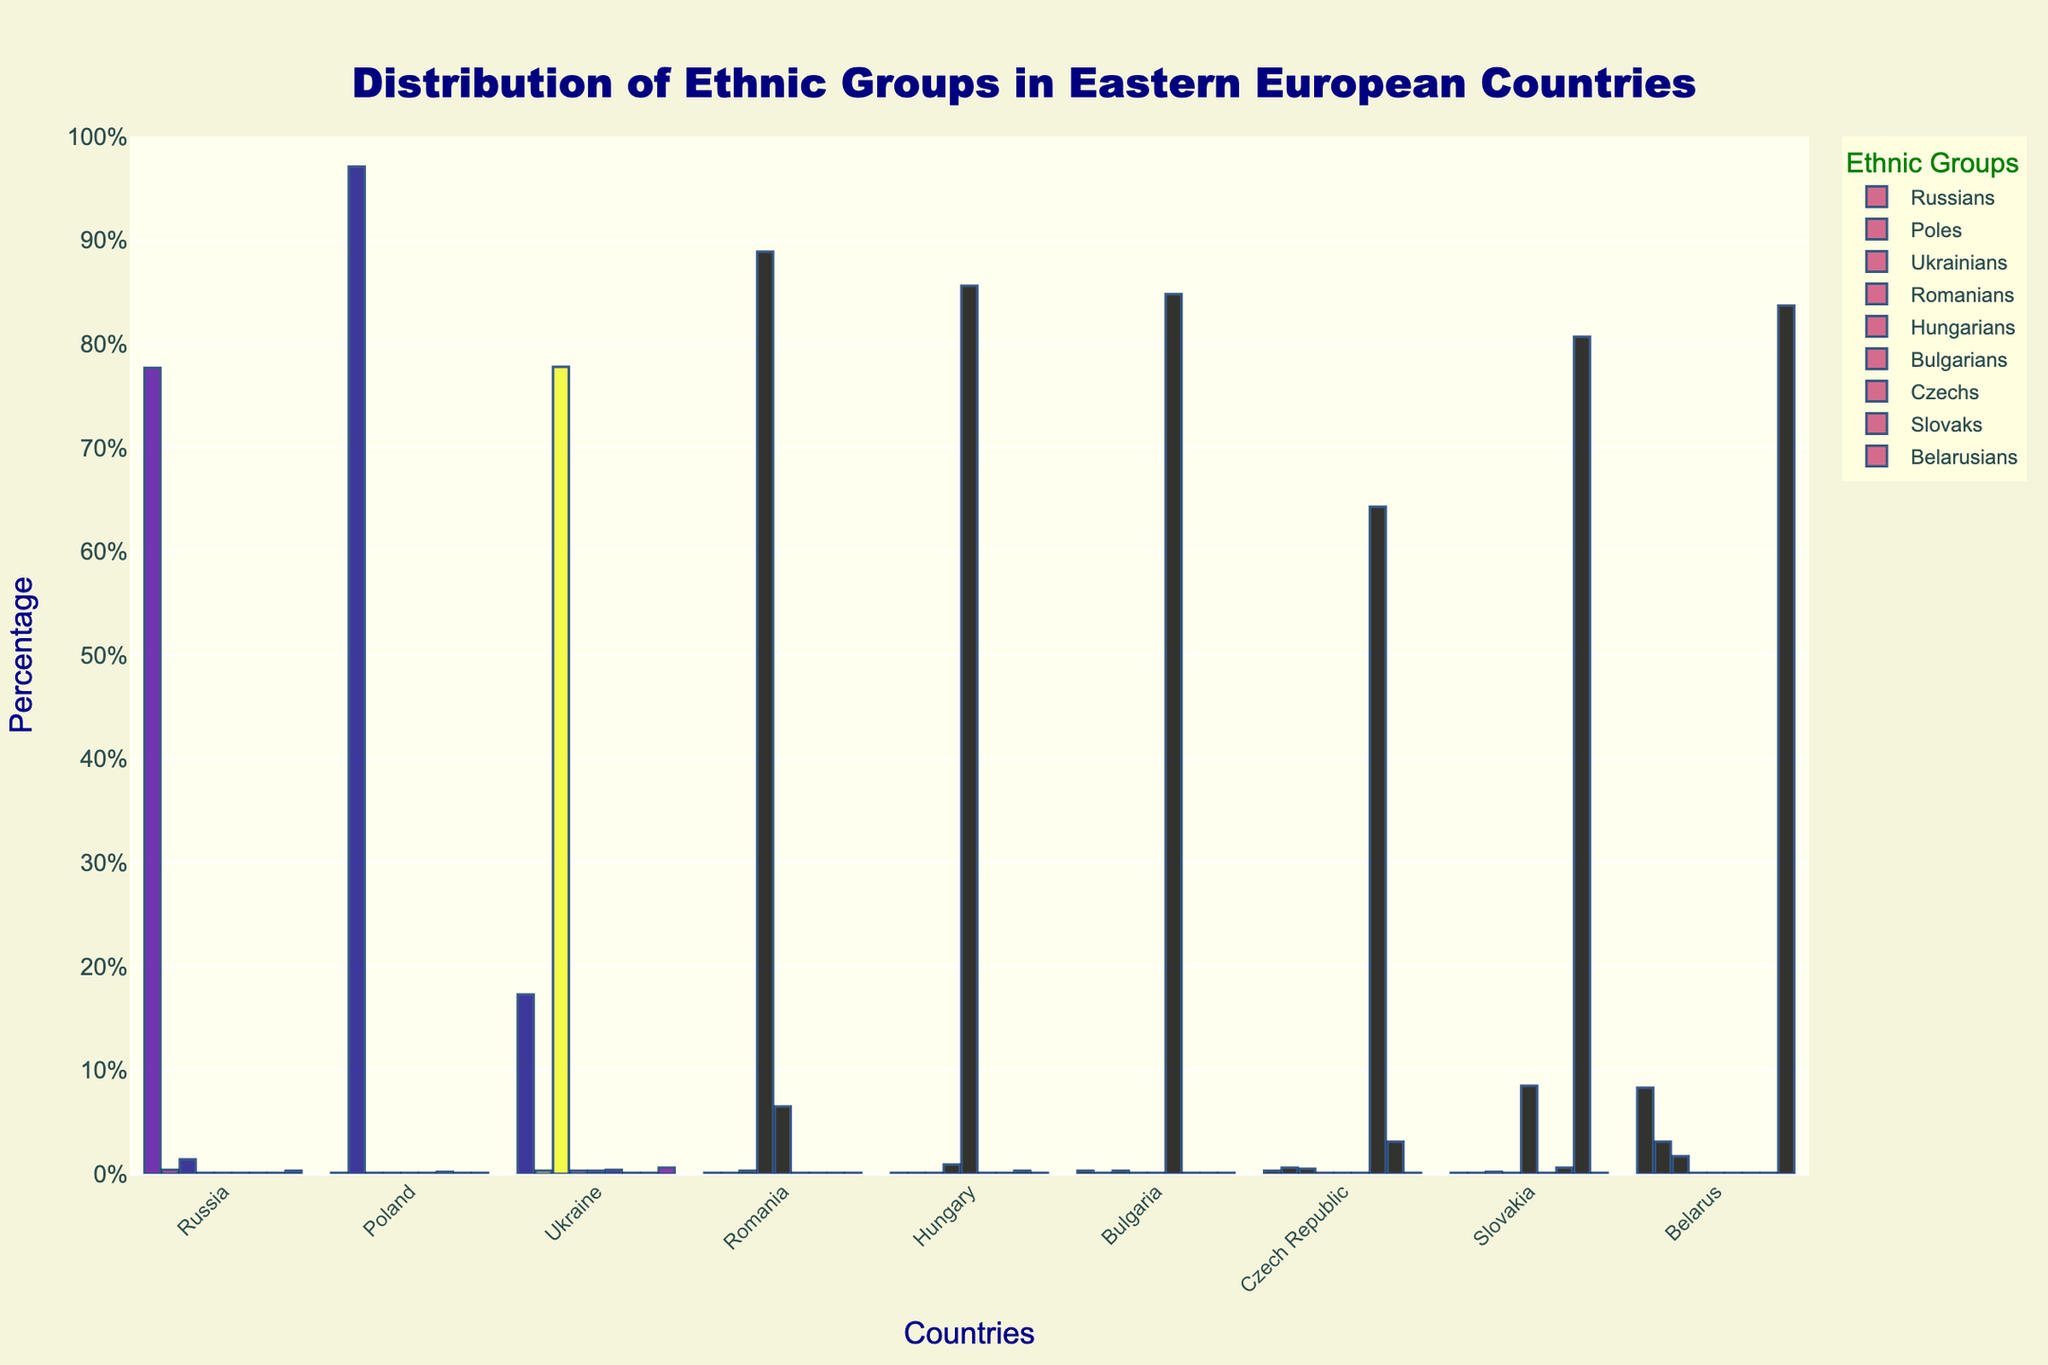What is the percentage difference between the Russian population in Russia and the Polish population in Poland? First, identify the Russian population percentage in Russia (77.7%) and the Polish population percentage in Poland (97.1%). Subtract 77.7% from 97.1% to find the difference.
Answer: 19.4% Which country has the highest percentage of Hungarians? Look at the bar heights for the Hungarian population across all countries and find the highest one, which is in Hungary with 85.6%.
Answer: Hungary Are there more Ukrainians in Ukraine or Russians in Belarus? Compare the bar heights or values for Ukrainians in Ukraine (77.8%) and Russians in Belarus (8.3%). 77.8% is greater than 8.3%.
Answer: More Ukrainians in Ukraine Which ethnic group has the smallest percentage in Slovakia? Examine the lowest bar height for Slovakia across all ethnic groups, which for multiple groups is a small value of 0.1%.
Answer: Multiple groups (including Russians, Poles, Romanians, and others) What is the combined percentage of Czechs and Slovaks in Slovakia? Add the percentage of Czechs (0.6%) to Slovaks (80.7%) in Slovakia. 0.6% + 80.7% = 81.3%.
Answer: 81.3% In which country do Poles make up a significant minority? Identify where the percentage bar for Poles is noticeably higher than in other countries, which is Belarus with 3.1%.
Answer: Belarus What is the average percentage of Russians across all the listed countries? Sum the percentages of Russians in each country (77.7 + 0.1 + 17.3 + 0.1 + 0.1 + 0.3 + 0.3 + 0.1 + 8.3 = 104.3) and divide by the number of countries (9). 104.3 / 9 ≈ 11.59%.
Answer: ≈ 11.59% Which country shows the highest ethnic diversity based on the chart? Compare how spread out and numerous the ethnic group bars are in each country. The Czech Republic has notable percentages across multiple groups, indicating higher diversity.
Answer: Czech Republic 